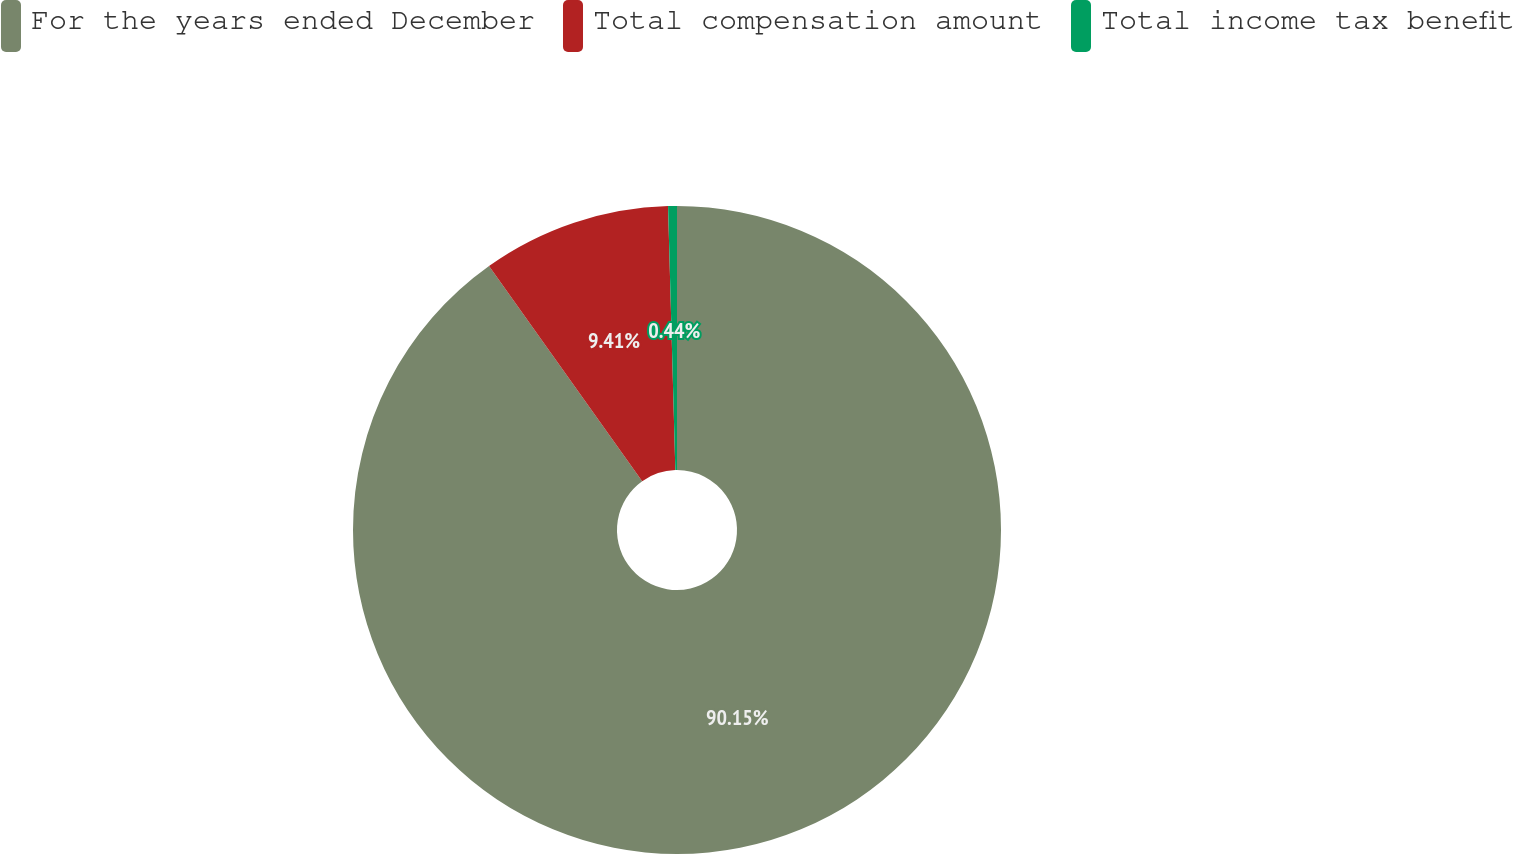Convert chart. <chart><loc_0><loc_0><loc_500><loc_500><pie_chart><fcel>For the years ended December<fcel>Total compensation amount<fcel>Total income tax benefit<nl><fcel>90.14%<fcel>9.41%<fcel>0.44%<nl></chart> 